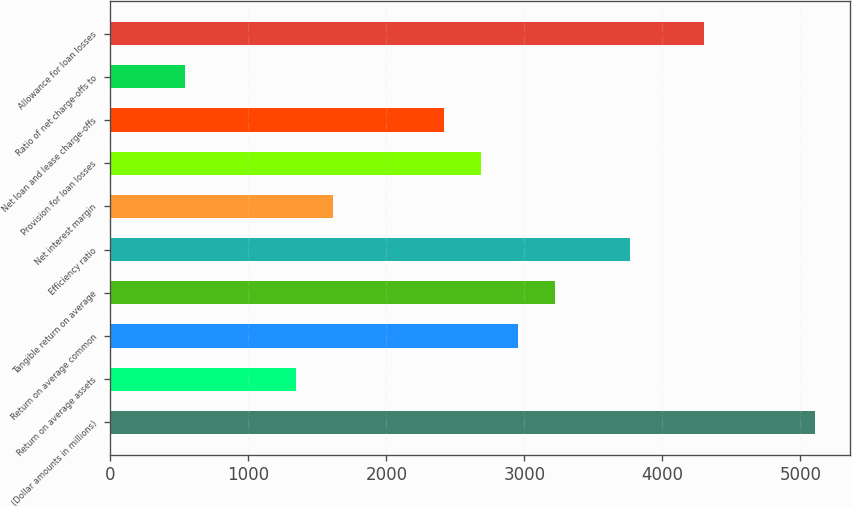<chart> <loc_0><loc_0><loc_500><loc_500><bar_chart><fcel>(Dollar amounts in millions)<fcel>Return on average assets<fcel>Return on average common<fcel>Tangible return on average<fcel>Efficiency ratio<fcel>Net interest margin<fcel>Provision for loan losses<fcel>Net loan and lease charge-offs<fcel>Ratio of net charge-offs to<fcel>Allowance for loan losses<nl><fcel>5105.19<fcel>1343.53<fcel>2955.67<fcel>3224.36<fcel>3761.74<fcel>1612.22<fcel>2686.98<fcel>2418.29<fcel>537.46<fcel>4299.12<nl></chart> 